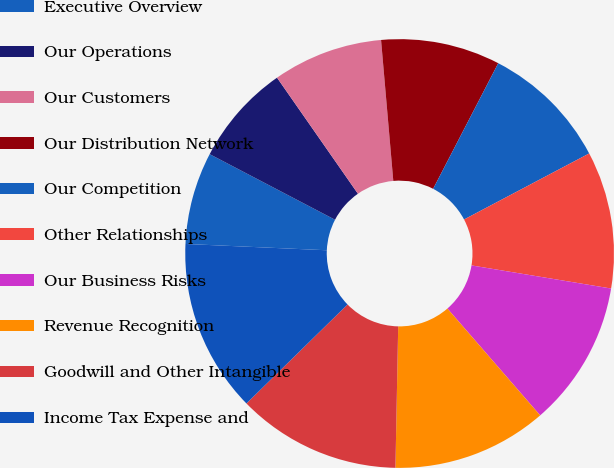Convert chart. <chart><loc_0><loc_0><loc_500><loc_500><pie_chart><fcel>Executive Overview<fcel>Our Operations<fcel>Our Customers<fcel>Our Distribution Network<fcel>Our Competition<fcel>Other Relationships<fcel>Our Business Risks<fcel>Revenue Recognition<fcel>Goodwill and Other Intangible<fcel>Income Tax Expense and<nl><fcel>6.96%<fcel>7.64%<fcel>8.31%<fcel>8.99%<fcel>9.66%<fcel>10.34%<fcel>11.01%<fcel>11.69%<fcel>12.36%<fcel>13.04%<nl></chart> 